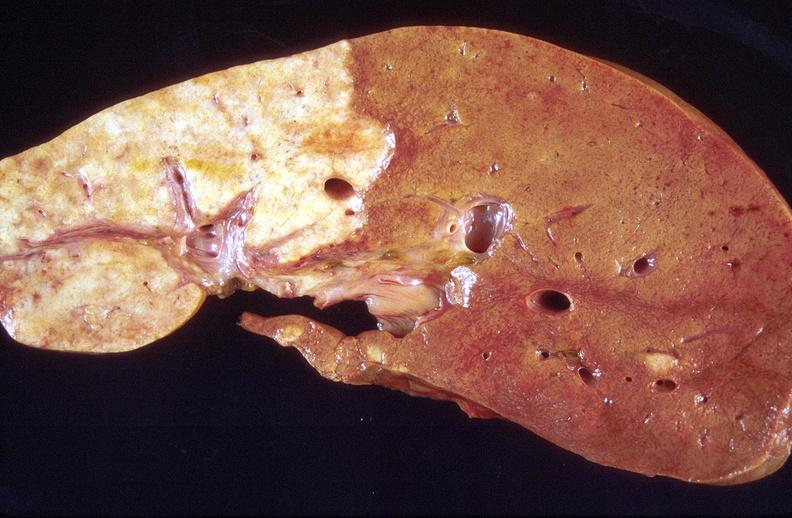what does this image show?
Answer the question using a single word or phrase. Cholangiocarcinoma 